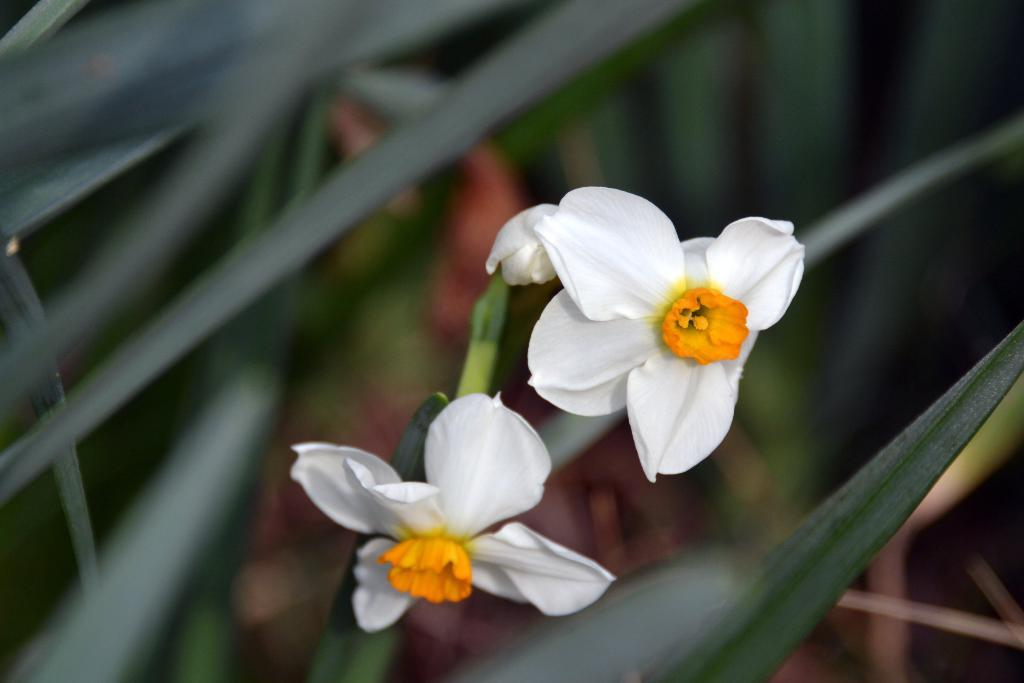What is the main subject of the image? The main subject of the image is a plant. Can you describe the flowers on the plant? The plant has two white flowers. What can be observed about the background of the image? The background of the image is blurred. How many eggs are visible on the plant in the image? There are no eggs visible on the plant in the image. What type of rings can be seen on the plant's leaves? There are no rings present on the plant's leaves in the image. 